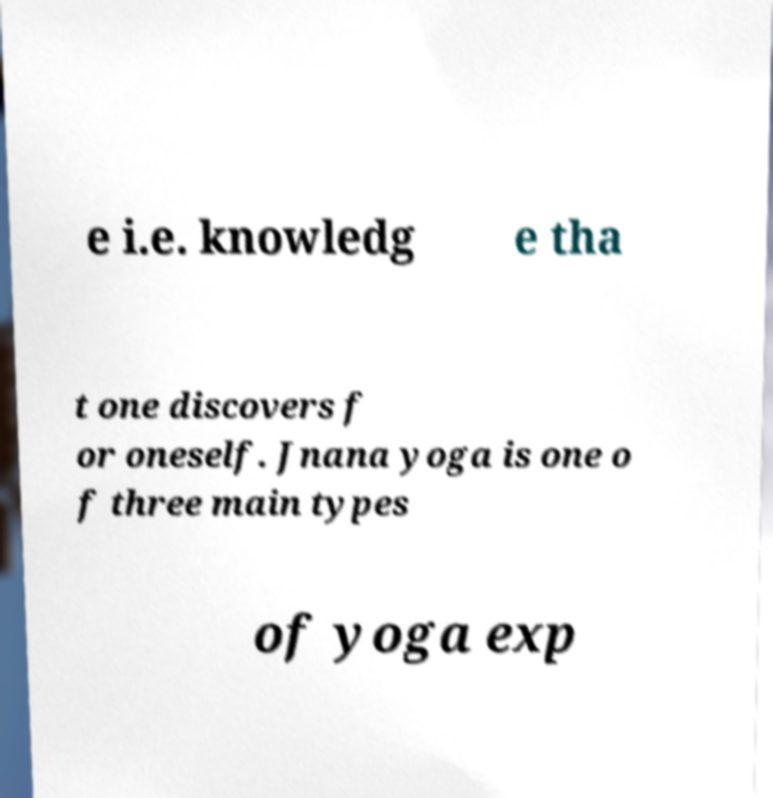Could you extract and type out the text from this image? e i.e. knowledg e tha t one discovers f or oneself. Jnana yoga is one o f three main types of yoga exp 